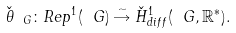Convert formula to latex. <formula><loc_0><loc_0><loc_500><loc_500>\check { \theta } _ { \ G } \colon R e p ^ { 1 } ( \ G ) \stackrel { \sim } { \rightarrow } \check { H } ^ { 1 } _ { d i f f } ( \ G , \mathbb { R } ^ { * } ) .</formula> 